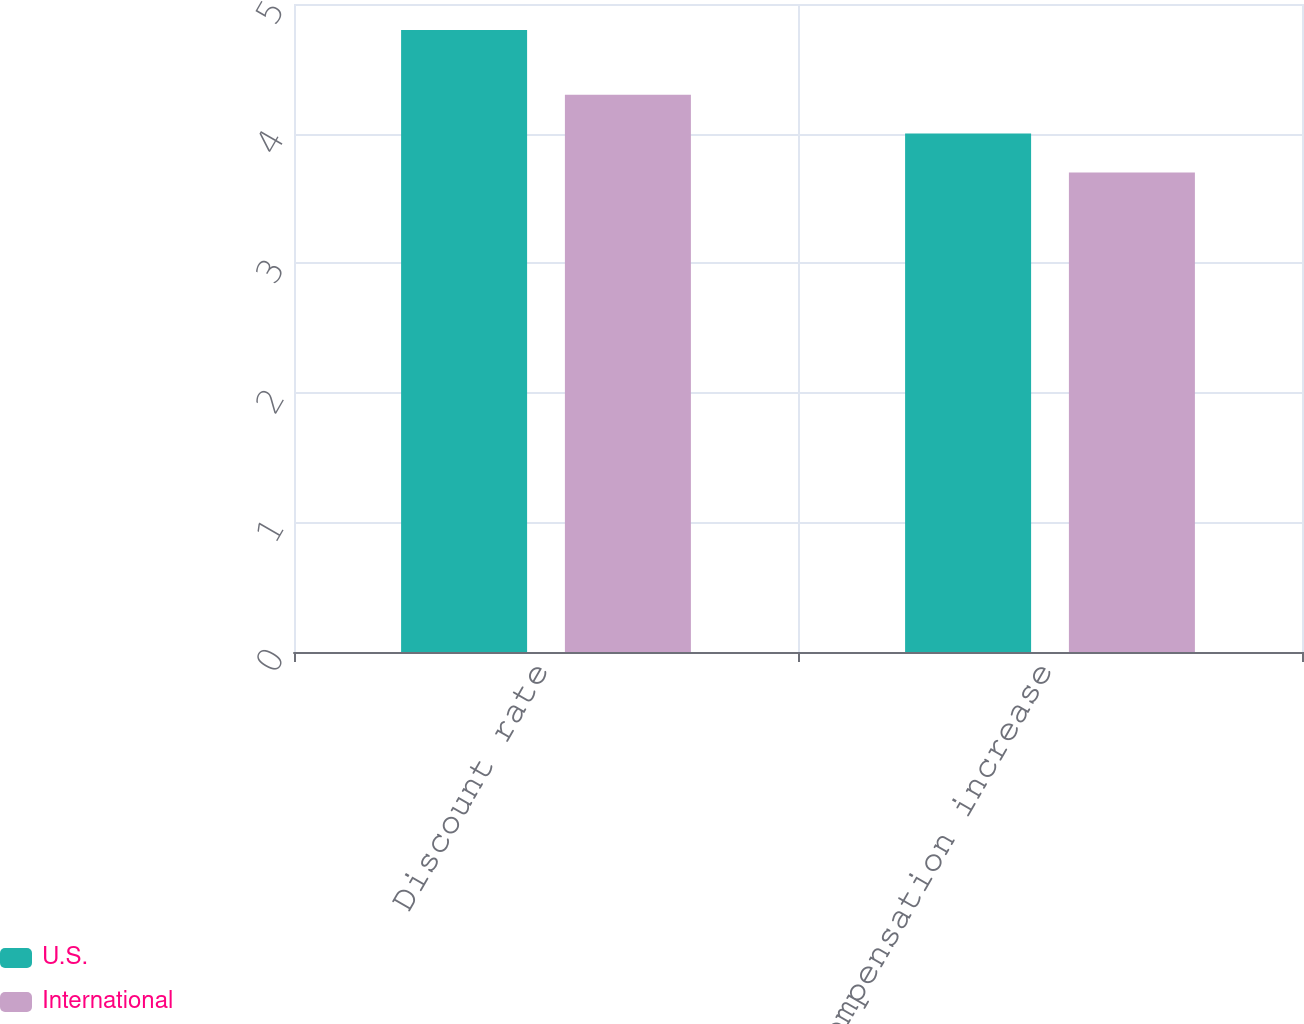Convert chart. <chart><loc_0><loc_0><loc_500><loc_500><stacked_bar_chart><ecel><fcel>Discount rate<fcel>Rate of compensation increase<nl><fcel>U.S.<fcel>4.8<fcel>4<nl><fcel>International<fcel>4.3<fcel>3.7<nl></chart> 